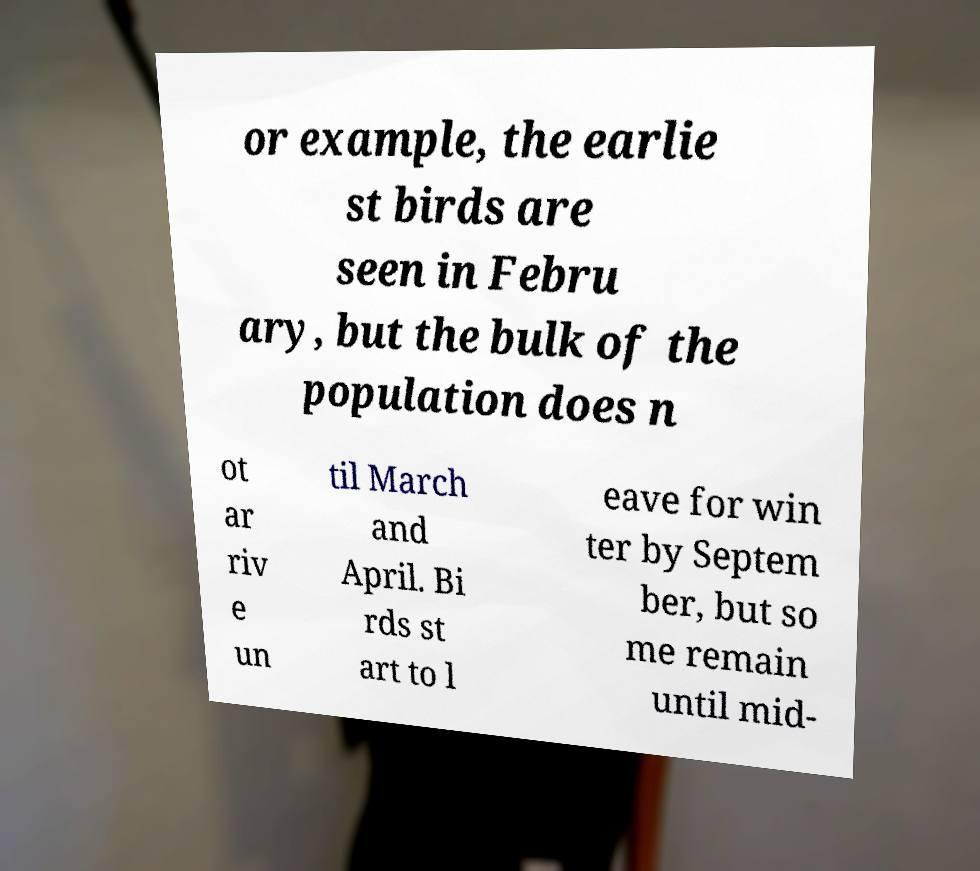What messages or text are displayed in this image? I need them in a readable, typed format. or example, the earlie st birds are seen in Febru ary, but the bulk of the population does n ot ar riv e un til March and April. Bi rds st art to l eave for win ter by Septem ber, but so me remain until mid- 